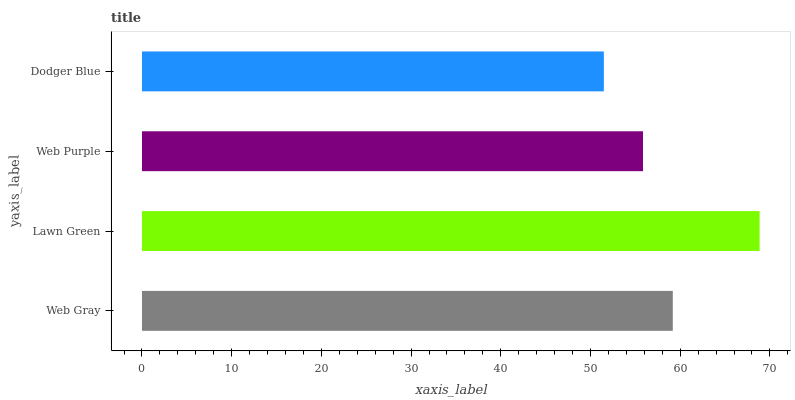Is Dodger Blue the minimum?
Answer yes or no. Yes. Is Lawn Green the maximum?
Answer yes or no. Yes. Is Web Purple the minimum?
Answer yes or no. No. Is Web Purple the maximum?
Answer yes or no. No. Is Lawn Green greater than Web Purple?
Answer yes or no. Yes. Is Web Purple less than Lawn Green?
Answer yes or no. Yes. Is Web Purple greater than Lawn Green?
Answer yes or no. No. Is Lawn Green less than Web Purple?
Answer yes or no. No. Is Web Gray the high median?
Answer yes or no. Yes. Is Web Purple the low median?
Answer yes or no. Yes. Is Lawn Green the high median?
Answer yes or no. No. Is Web Gray the low median?
Answer yes or no. No. 